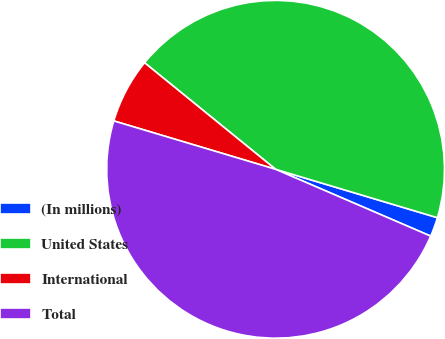Convert chart. <chart><loc_0><loc_0><loc_500><loc_500><pie_chart><fcel>(In millions)<fcel>United States<fcel>International<fcel>Total<nl><fcel>1.85%<fcel>43.76%<fcel>6.24%<fcel>48.15%<nl></chart> 